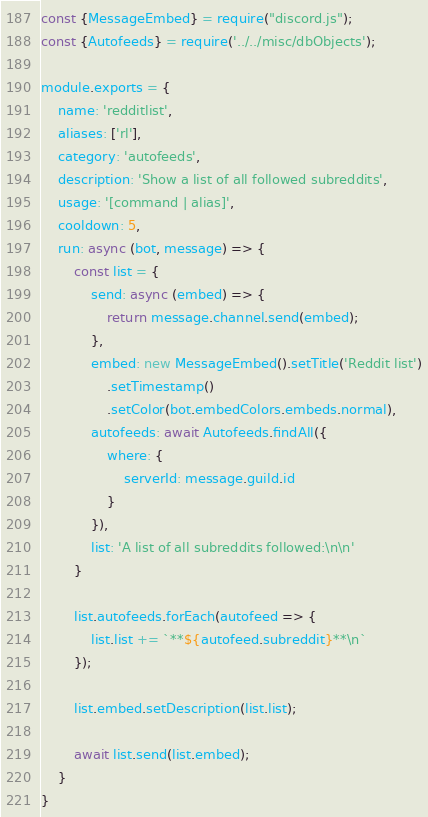<code> <loc_0><loc_0><loc_500><loc_500><_JavaScript_>const {MessageEmbed} = require("discord.js");
const {Autofeeds} = require('../../misc/dbObjects');

module.exports = {
    name: 'redditlist',
    aliases: ['rl'],
    category: 'autofeeds',
    description: 'Show a list of all followed subreddits',
    usage: '[command | alias]',
    cooldown: 5,
    run: async (bot, message) => {
        const list = {
            send: async (embed) => {
                return message.channel.send(embed);
            },
            embed: new MessageEmbed().setTitle('Reddit list')
                .setTimestamp()
                .setColor(bot.embedColors.embeds.normal),
            autofeeds: await Autofeeds.findAll({
                where: {
                    serverId: message.guild.id
                }
            }),
            list: 'A list of all subreddits followed:\n\n'
        }

        list.autofeeds.forEach(autofeed => {
            list.list += `**${autofeed.subreddit}**\n`
        });

        list.embed.setDescription(list.list);

        await list.send(list.embed);
    }
}</code> 